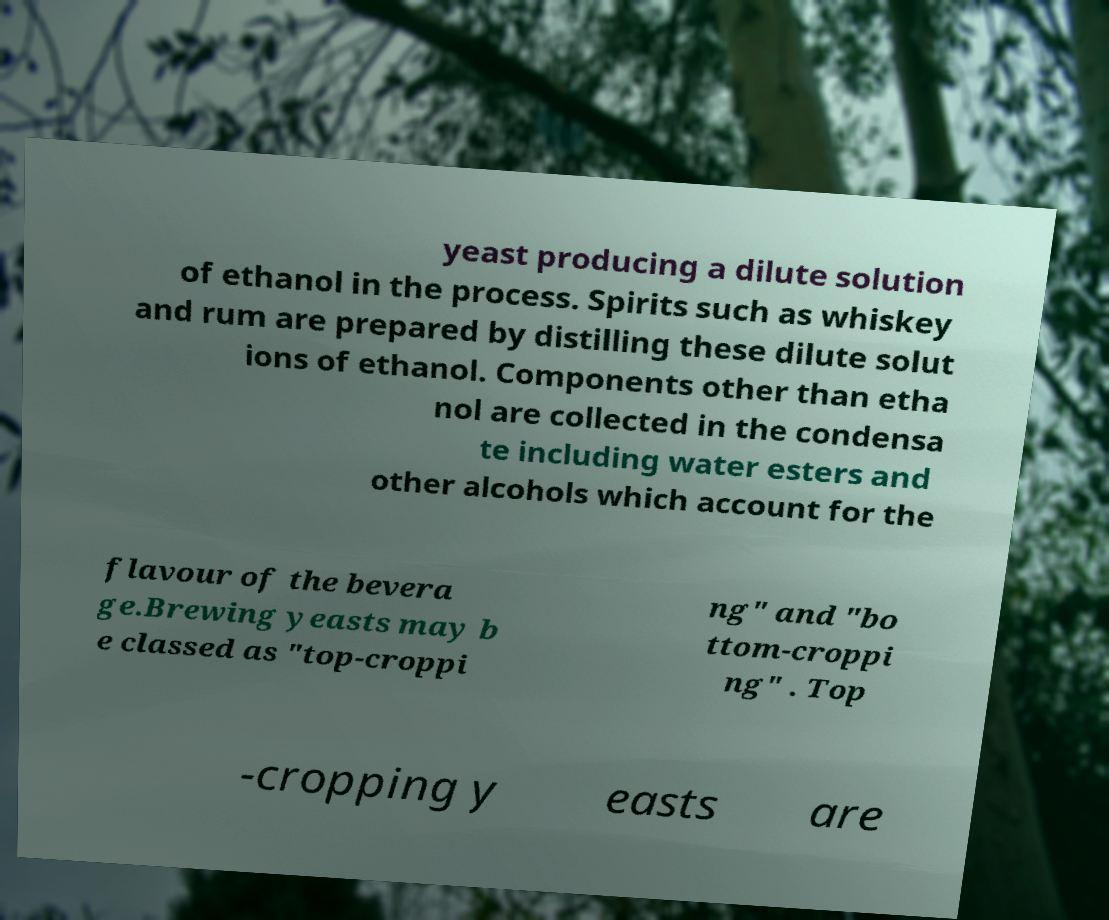There's text embedded in this image that I need extracted. Can you transcribe it verbatim? yeast producing a dilute solution of ethanol in the process. Spirits such as whiskey and rum are prepared by distilling these dilute solut ions of ethanol. Components other than etha nol are collected in the condensa te including water esters and other alcohols which account for the flavour of the bevera ge.Brewing yeasts may b e classed as "top-croppi ng" and "bo ttom-croppi ng" . Top -cropping y easts are 